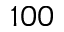<formula> <loc_0><loc_0><loc_500><loc_500>1 0 0</formula> 